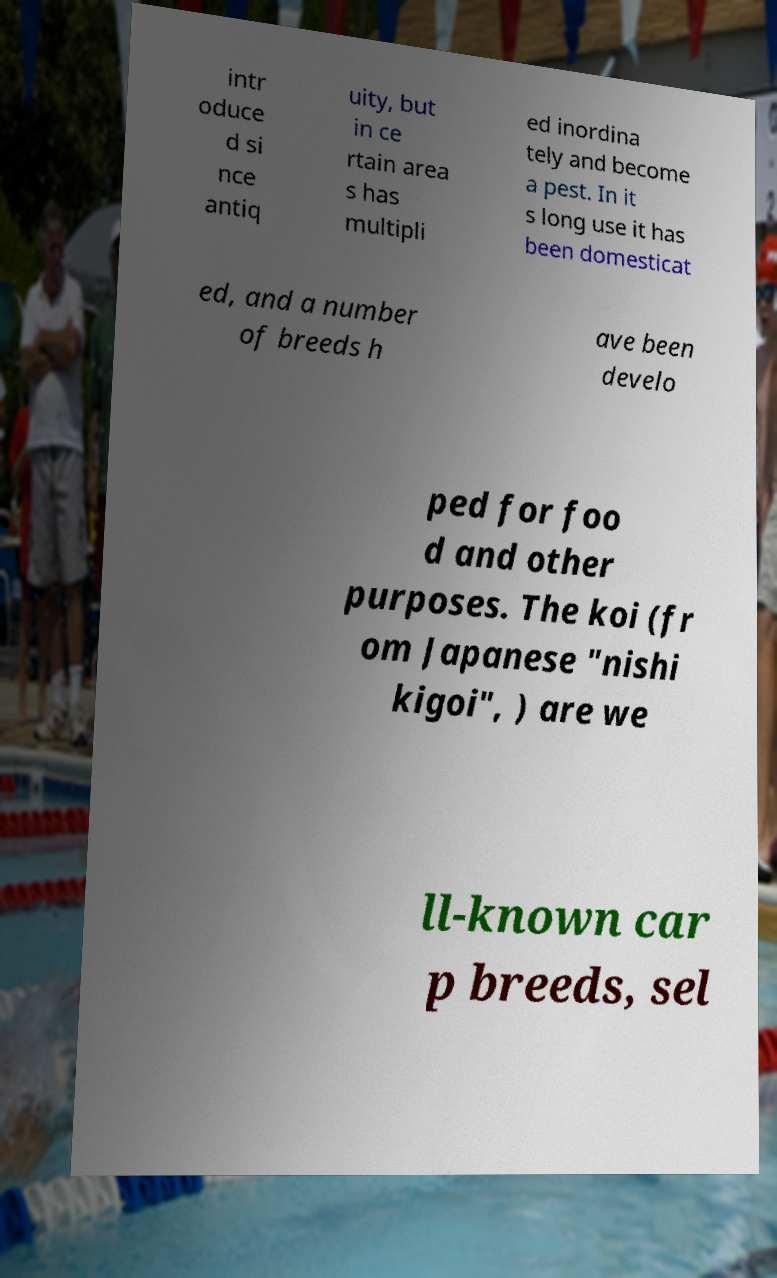Please identify and transcribe the text found in this image. intr oduce d si nce antiq uity, but in ce rtain area s has multipli ed inordina tely and become a pest. In it s long use it has been domesticat ed, and a number of breeds h ave been develo ped for foo d and other purposes. The koi (fr om Japanese "nishi kigoi", ) are we ll-known car p breeds, sel 